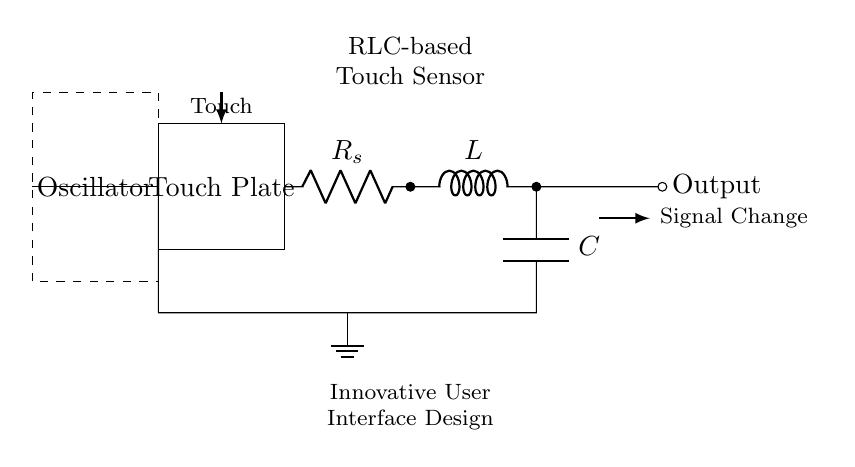What component is used for storing charge? The capacitor, labeled with a "C" in the circuit, is specifically designed to store electrical energy in an electric field.
Answer: Capacitor What type of circuit is this? This is an RLC circuit, which contains a resistor (R), an inductor (L), and a capacitor (C) connected in a series or parallel configuration.
Answer: RLC circuit How is the touch plate connected in the circuit? The touch plate is connected to the resistor at one end and serves as the input to the oscillator, indicating that it influences the circuit's behavior when touched.
Answer: To the resistor What happens to the output signal when the touch plate is activated? When the touch plate is activated, the oscillator detects the change in capacitance due to touch, leading to a change in the output signal indicating user interaction.
Answer: Signal Change What is the role of the inductor in this circuit? The inductor provides inductive reactance, which contributes to the overall impedance of the circuit, affecting how the circuit responds to AC signals and touch inputs.
Answer: Inductive reactance What does the dashed box represent? The dashed box represents the oscillator, which generates alternating current to allow the touch sensor to function effectively by interacting with the RLC components.
Answer: Oscillator What is the purpose of the ground in this circuit? The ground serves as a return path for current and a reference point for voltage, ensuring stability and safety in the circuit operation.
Answer: Stability reference 